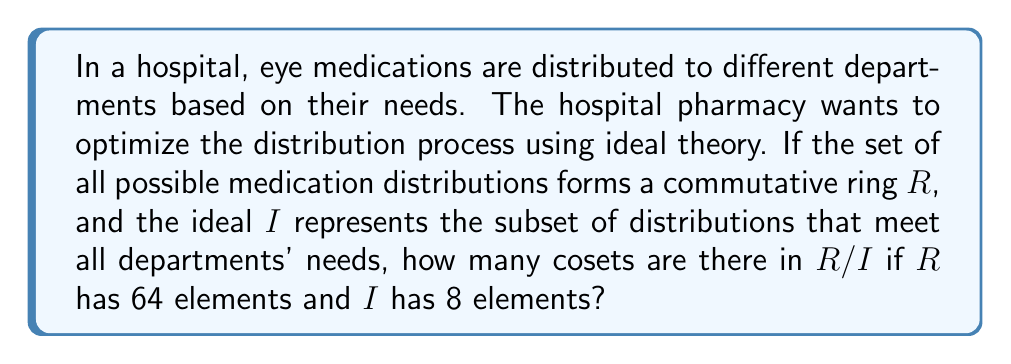Help me with this question. To solve this problem, we'll use the following steps:

1) First, recall that in ring theory, the number of cosets in a quotient ring $R/I$ is equal to the index of $I$ in $R$, denoted as $[R:I]$.

2) The index $[R:I]$ is calculated by dividing the number of elements in $R$ by the number of elements in $I$:

   $$[R:I] = \frac{|R|}{|I|}$$

3) We are given that:
   - $R$ has 64 elements, so $|R| = 64$
   - $I$ has 8 elements, so $|I| = 8$

4) Substituting these values into our formula:

   $$[R:I] = \frac{|R|}{|I|} = \frac{64}{8} = 8$$

5) Therefore, there are 8 cosets in $R/I$.

This result means that the hospital can optimize its medication distribution into 8 distinct categories or patterns, each represented by a coset. Each of these categories would ensure that all departments' needs are met (as defined by the ideal $I$) while providing a structured way to manage the overall distribution process.
Answer: 8 cosets 